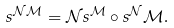<formula> <loc_0><loc_0><loc_500><loc_500>{ s } ^ { \mathcal { N } \mathcal { M } } = \mathcal { N } { s } ^ { \mathcal { M } } \circ { s } ^ { \mathcal { N } } \mathcal { M } .</formula> 